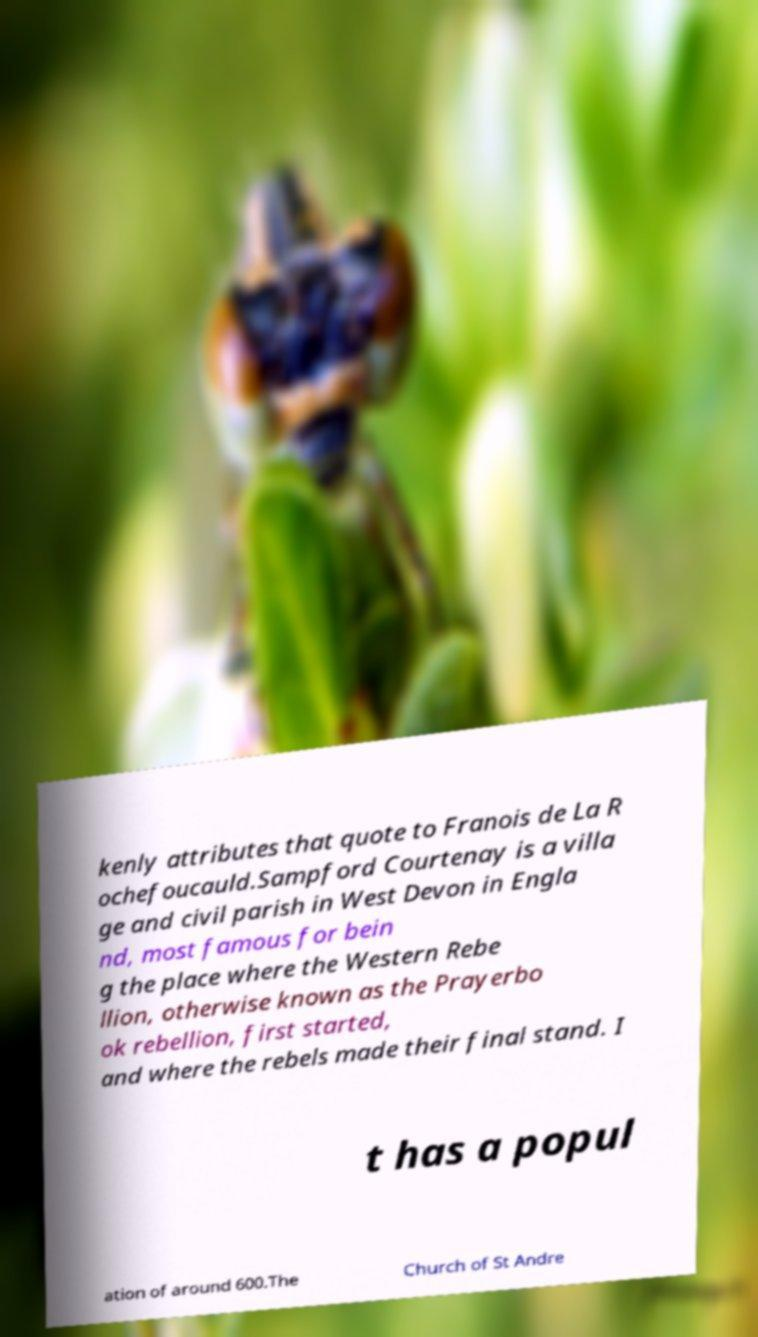Please identify and transcribe the text found in this image. kenly attributes that quote to Franois de La R ochefoucauld.Sampford Courtenay is a villa ge and civil parish in West Devon in Engla nd, most famous for bein g the place where the Western Rebe llion, otherwise known as the Prayerbo ok rebellion, first started, and where the rebels made their final stand. I t has a popul ation of around 600.The Church of St Andre 